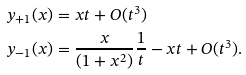<formula> <loc_0><loc_0><loc_500><loc_500>\ y _ { + 1 } ( x ) & = x t + O ( t ^ { 3 } ) \\ \ y _ { - 1 } ( x ) & = \frac { x } { ( 1 + x ^ { 2 } ) } \frac { 1 } { t } - x t + O ( t ^ { 3 } ) . \\</formula> 